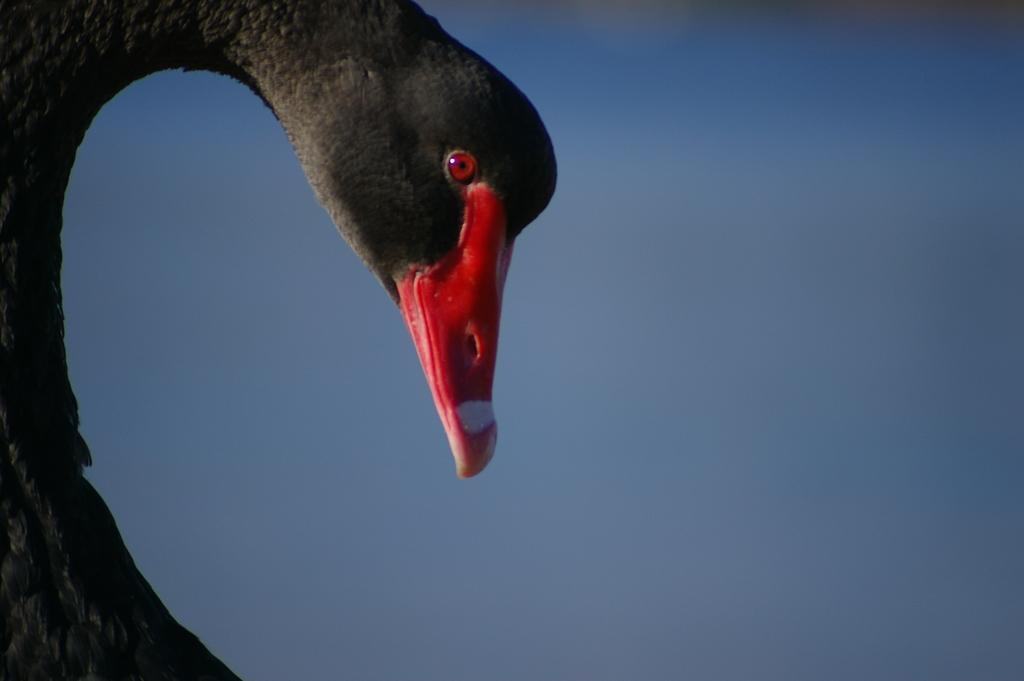What is the main subject of the image? The main subject of the image is the head of an animal. What color is the sky in the image? The sky is blue in the image. What is the price of the base in the image? There is no base present in the image, so it is not possible to determine its price. 